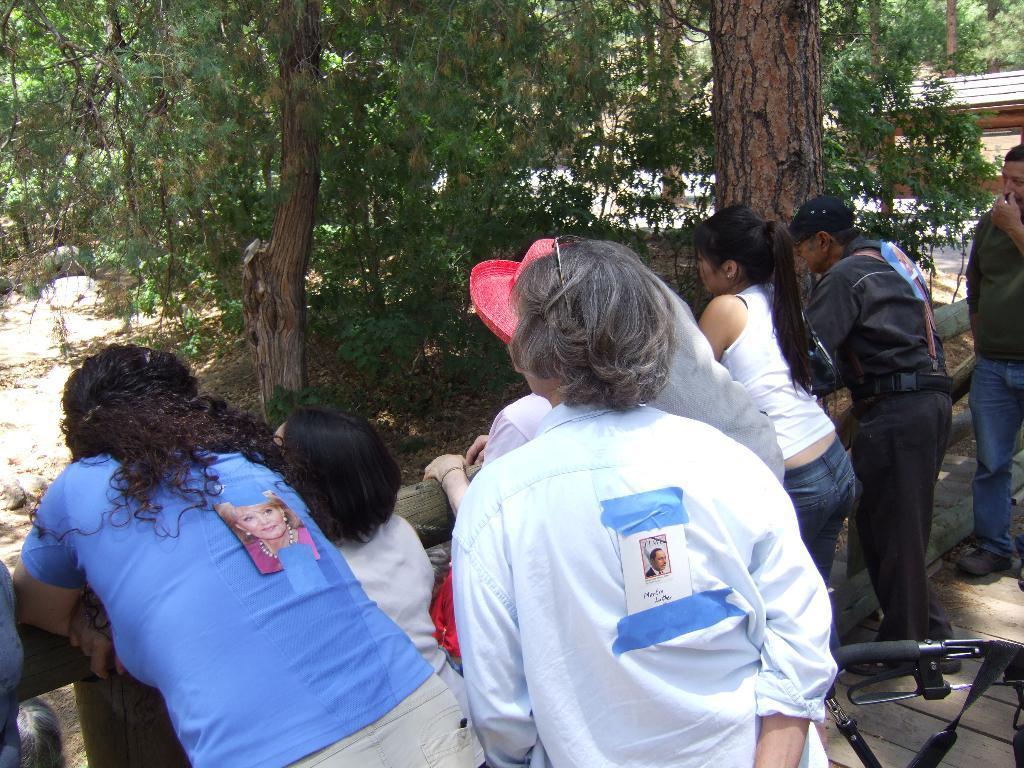Can you describe this image briefly? In this image there are a group of persons standing, there is a wooden fence, there is an object towards the right of the image, there is a wooden floor towards the right of the image, there are trees towards the top of the image, there is a tree trunk towards the top of the image, there is ground towards the left of the image. 